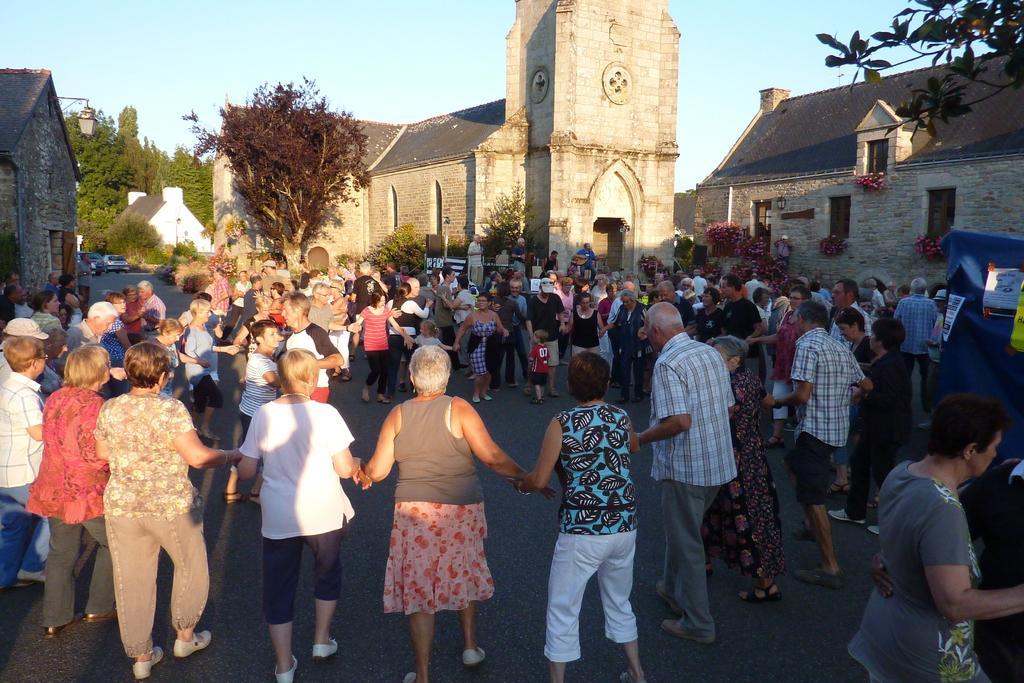How would you summarize this image in a sentence or two? In this image there are group of persons standing. In the background there are buildings, there are trees. On the right side there is a blue colour object with some posters. 